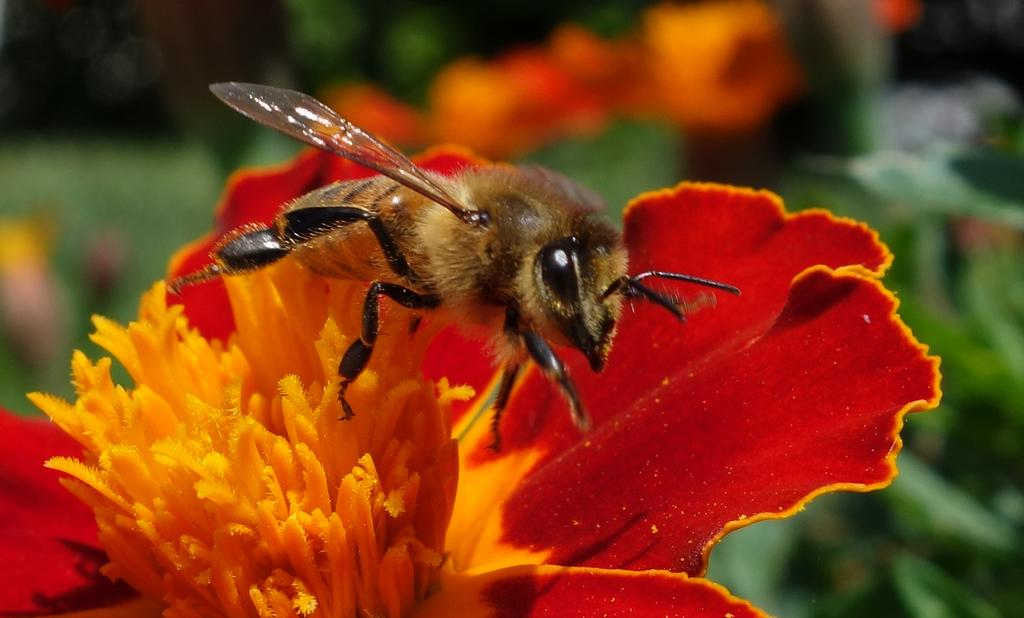What type of insect is present in the image? There is a honey bee in the image. What is the honey bee doing in the image? The honey bee is on a red flower. How many boys are present in the image? There are no boys present in the image; it features a honey bee on a red flower. What type of crook is visible in the image? There is no crook present in the image. 